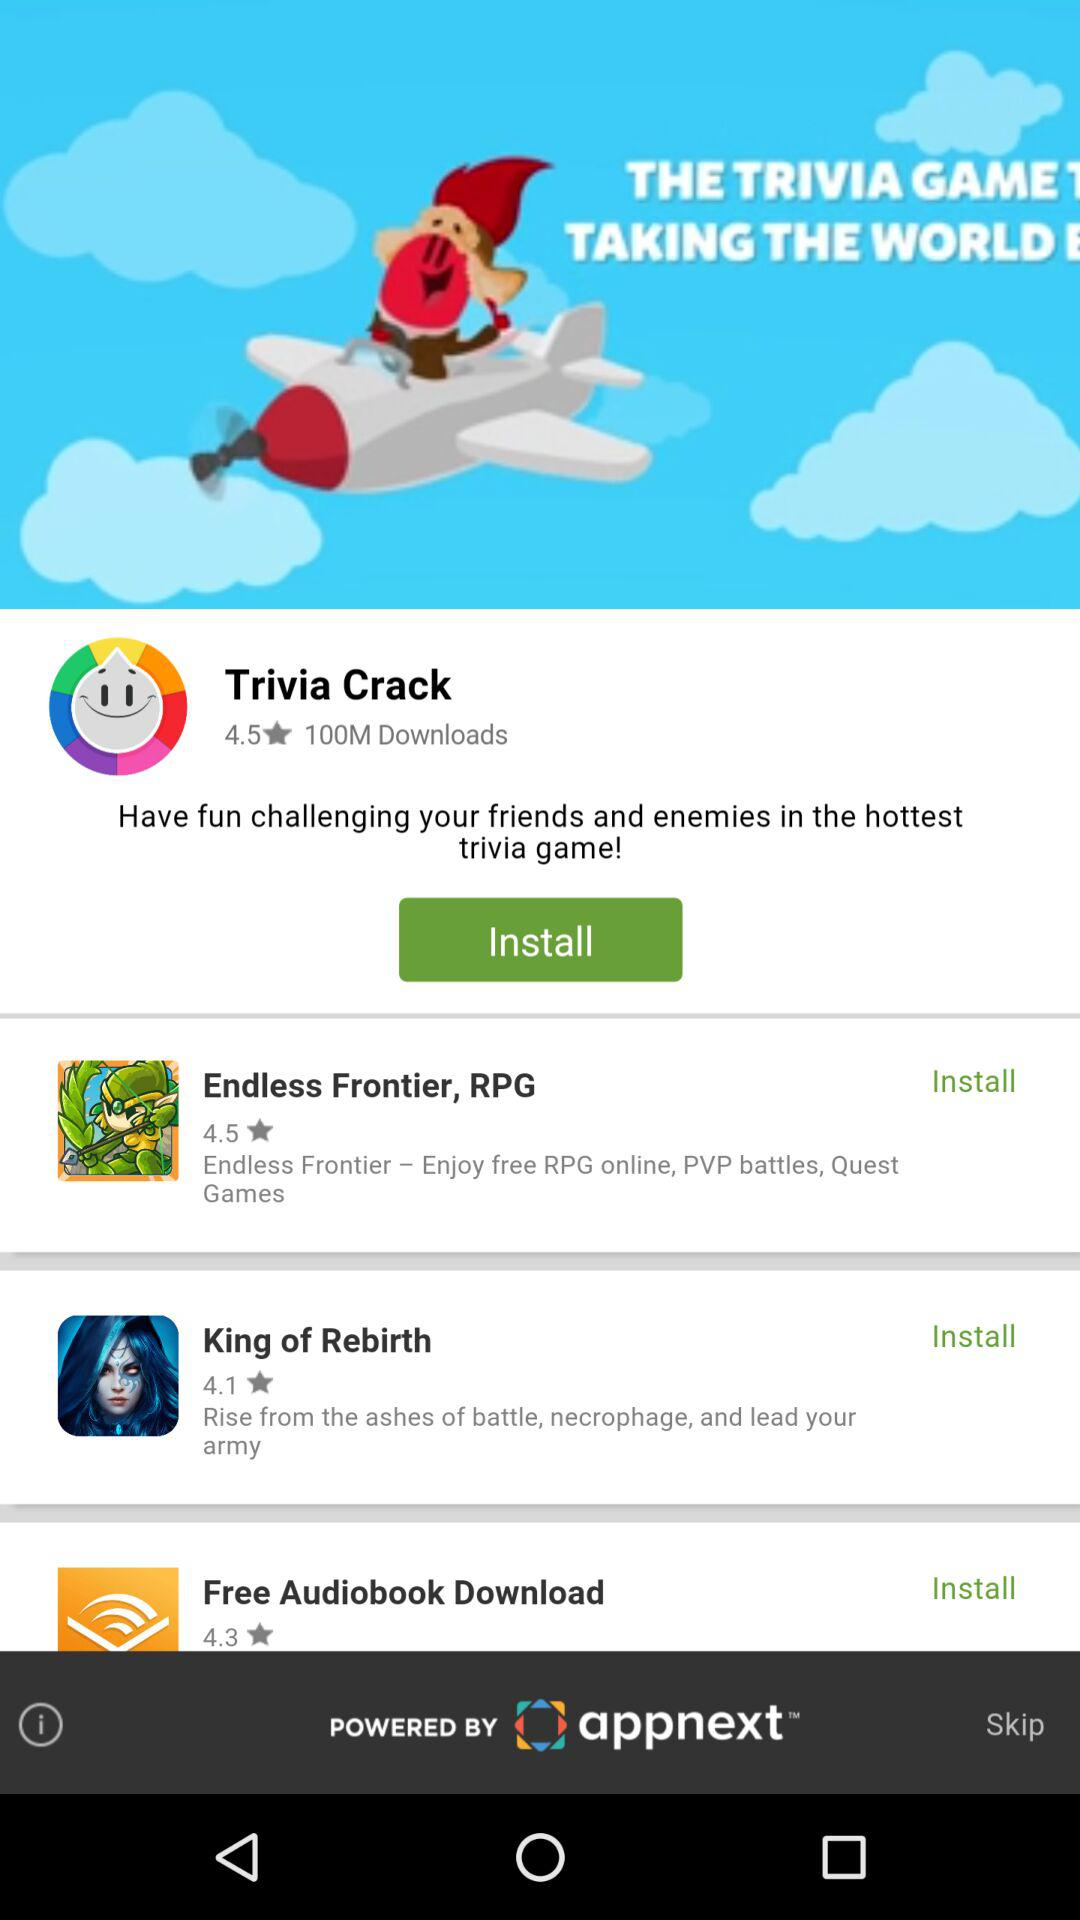What is the cost of downloading audiobooks?
When the provided information is insufficient, respond with <no answer>. <no answer> 